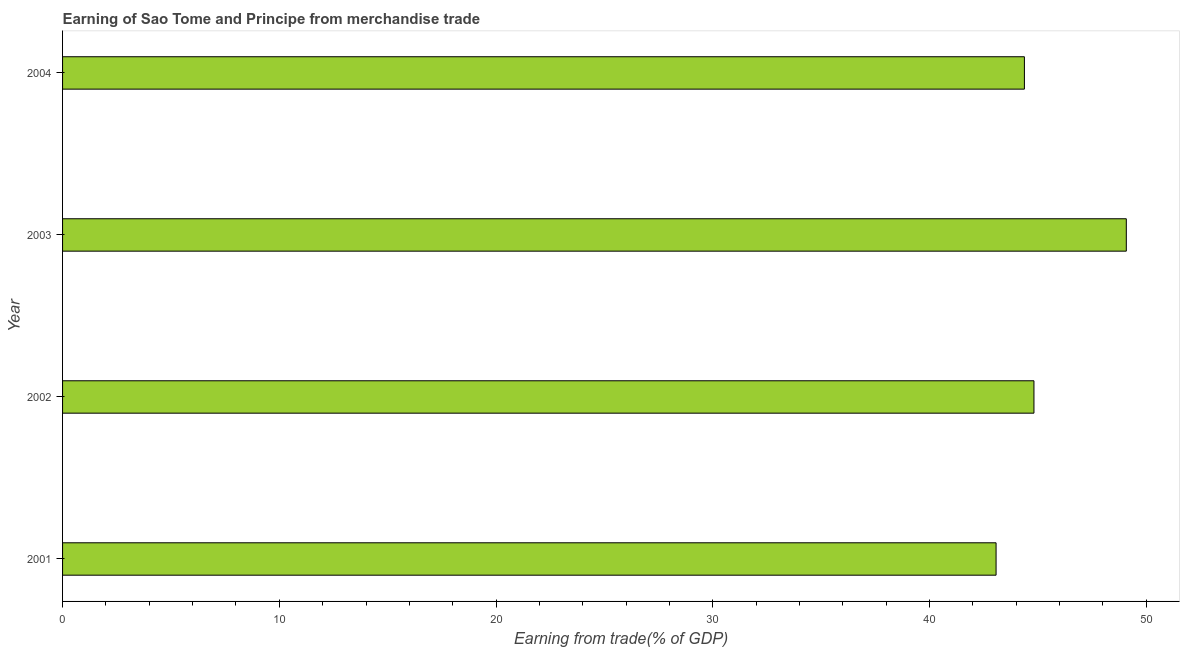What is the title of the graph?
Ensure brevity in your answer.  Earning of Sao Tome and Principe from merchandise trade. What is the label or title of the X-axis?
Ensure brevity in your answer.  Earning from trade(% of GDP). What is the earning from merchandise trade in 2004?
Offer a very short reply. 44.38. Across all years, what is the maximum earning from merchandise trade?
Your answer should be very brief. 49.08. Across all years, what is the minimum earning from merchandise trade?
Keep it short and to the point. 43.07. In which year was the earning from merchandise trade maximum?
Provide a short and direct response. 2003. What is the sum of the earning from merchandise trade?
Make the answer very short. 181.33. What is the difference between the earning from merchandise trade in 2001 and 2002?
Provide a succinct answer. -1.75. What is the average earning from merchandise trade per year?
Your response must be concise. 45.33. What is the median earning from merchandise trade?
Give a very brief answer. 44.6. Do a majority of the years between 2002 and 2004 (inclusive) have earning from merchandise trade greater than 6 %?
Give a very brief answer. Yes. What is the ratio of the earning from merchandise trade in 2002 to that in 2004?
Keep it short and to the point. 1.01. Is the earning from merchandise trade in 2003 less than that in 2004?
Give a very brief answer. No. Is the difference between the earning from merchandise trade in 2002 and 2004 greater than the difference between any two years?
Give a very brief answer. No. What is the difference between the highest and the second highest earning from merchandise trade?
Offer a terse response. 4.26. Is the sum of the earning from merchandise trade in 2001 and 2003 greater than the maximum earning from merchandise trade across all years?
Provide a short and direct response. Yes. What is the difference between the highest and the lowest earning from merchandise trade?
Provide a short and direct response. 6.01. How many bars are there?
Give a very brief answer. 4. What is the Earning from trade(% of GDP) of 2001?
Your answer should be very brief. 43.07. What is the Earning from trade(% of GDP) in 2002?
Offer a very short reply. 44.82. What is the Earning from trade(% of GDP) of 2003?
Provide a short and direct response. 49.08. What is the Earning from trade(% of GDP) of 2004?
Provide a short and direct response. 44.38. What is the difference between the Earning from trade(% of GDP) in 2001 and 2002?
Your response must be concise. -1.75. What is the difference between the Earning from trade(% of GDP) in 2001 and 2003?
Provide a short and direct response. -6.01. What is the difference between the Earning from trade(% of GDP) in 2001 and 2004?
Offer a very short reply. -1.31. What is the difference between the Earning from trade(% of GDP) in 2002 and 2003?
Offer a very short reply. -4.26. What is the difference between the Earning from trade(% of GDP) in 2002 and 2004?
Your answer should be compact. 0.44. What is the difference between the Earning from trade(% of GDP) in 2003 and 2004?
Offer a very short reply. 4.7. What is the ratio of the Earning from trade(% of GDP) in 2001 to that in 2003?
Provide a short and direct response. 0.88. What is the ratio of the Earning from trade(% of GDP) in 2001 to that in 2004?
Ensure brevity in your answer.  0.97. What is the ratio of the Earning from trade(% of GDP) in 2003 to that in 2004?
Your answer should be very brief. 1.11. 